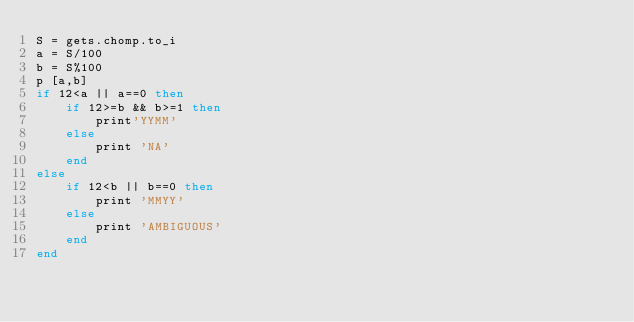Convert code to text. <code><loc_0><loc_0><loc_500><loc_500><_Ruby_>S = gets.chomp.to_i
a = S/100
b = S%100
p [a,b]
if 12<a || a==0 then
	if 12>=b && b>=1 then
		print'YYMM'
	else
		print 'NA'
	end
else
	if 12<b || b==0 then
		print 'MMYY'
	else
		print 'AMBIGUOUS'
	end
end</code> 